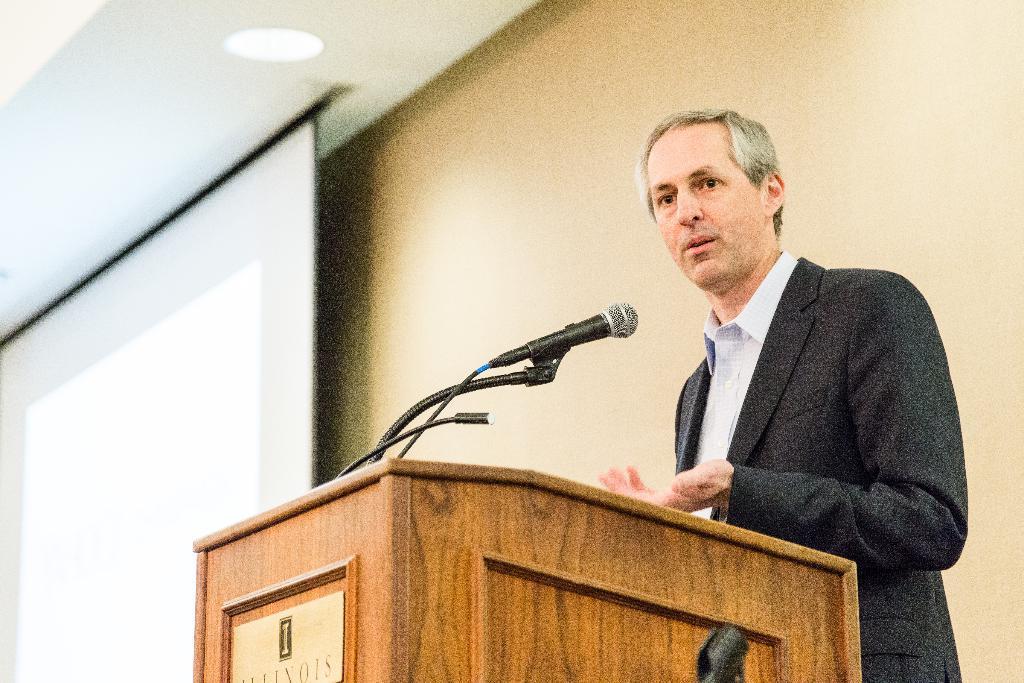Please provide a concise description of this image. In this picture, we can see a man in the black blazer is standing and explaining something and in front of the man there is a podium and on the podium there is a microphone with stand and behind the man there is a projector screen, wall and there is a ceiling light on the top. 